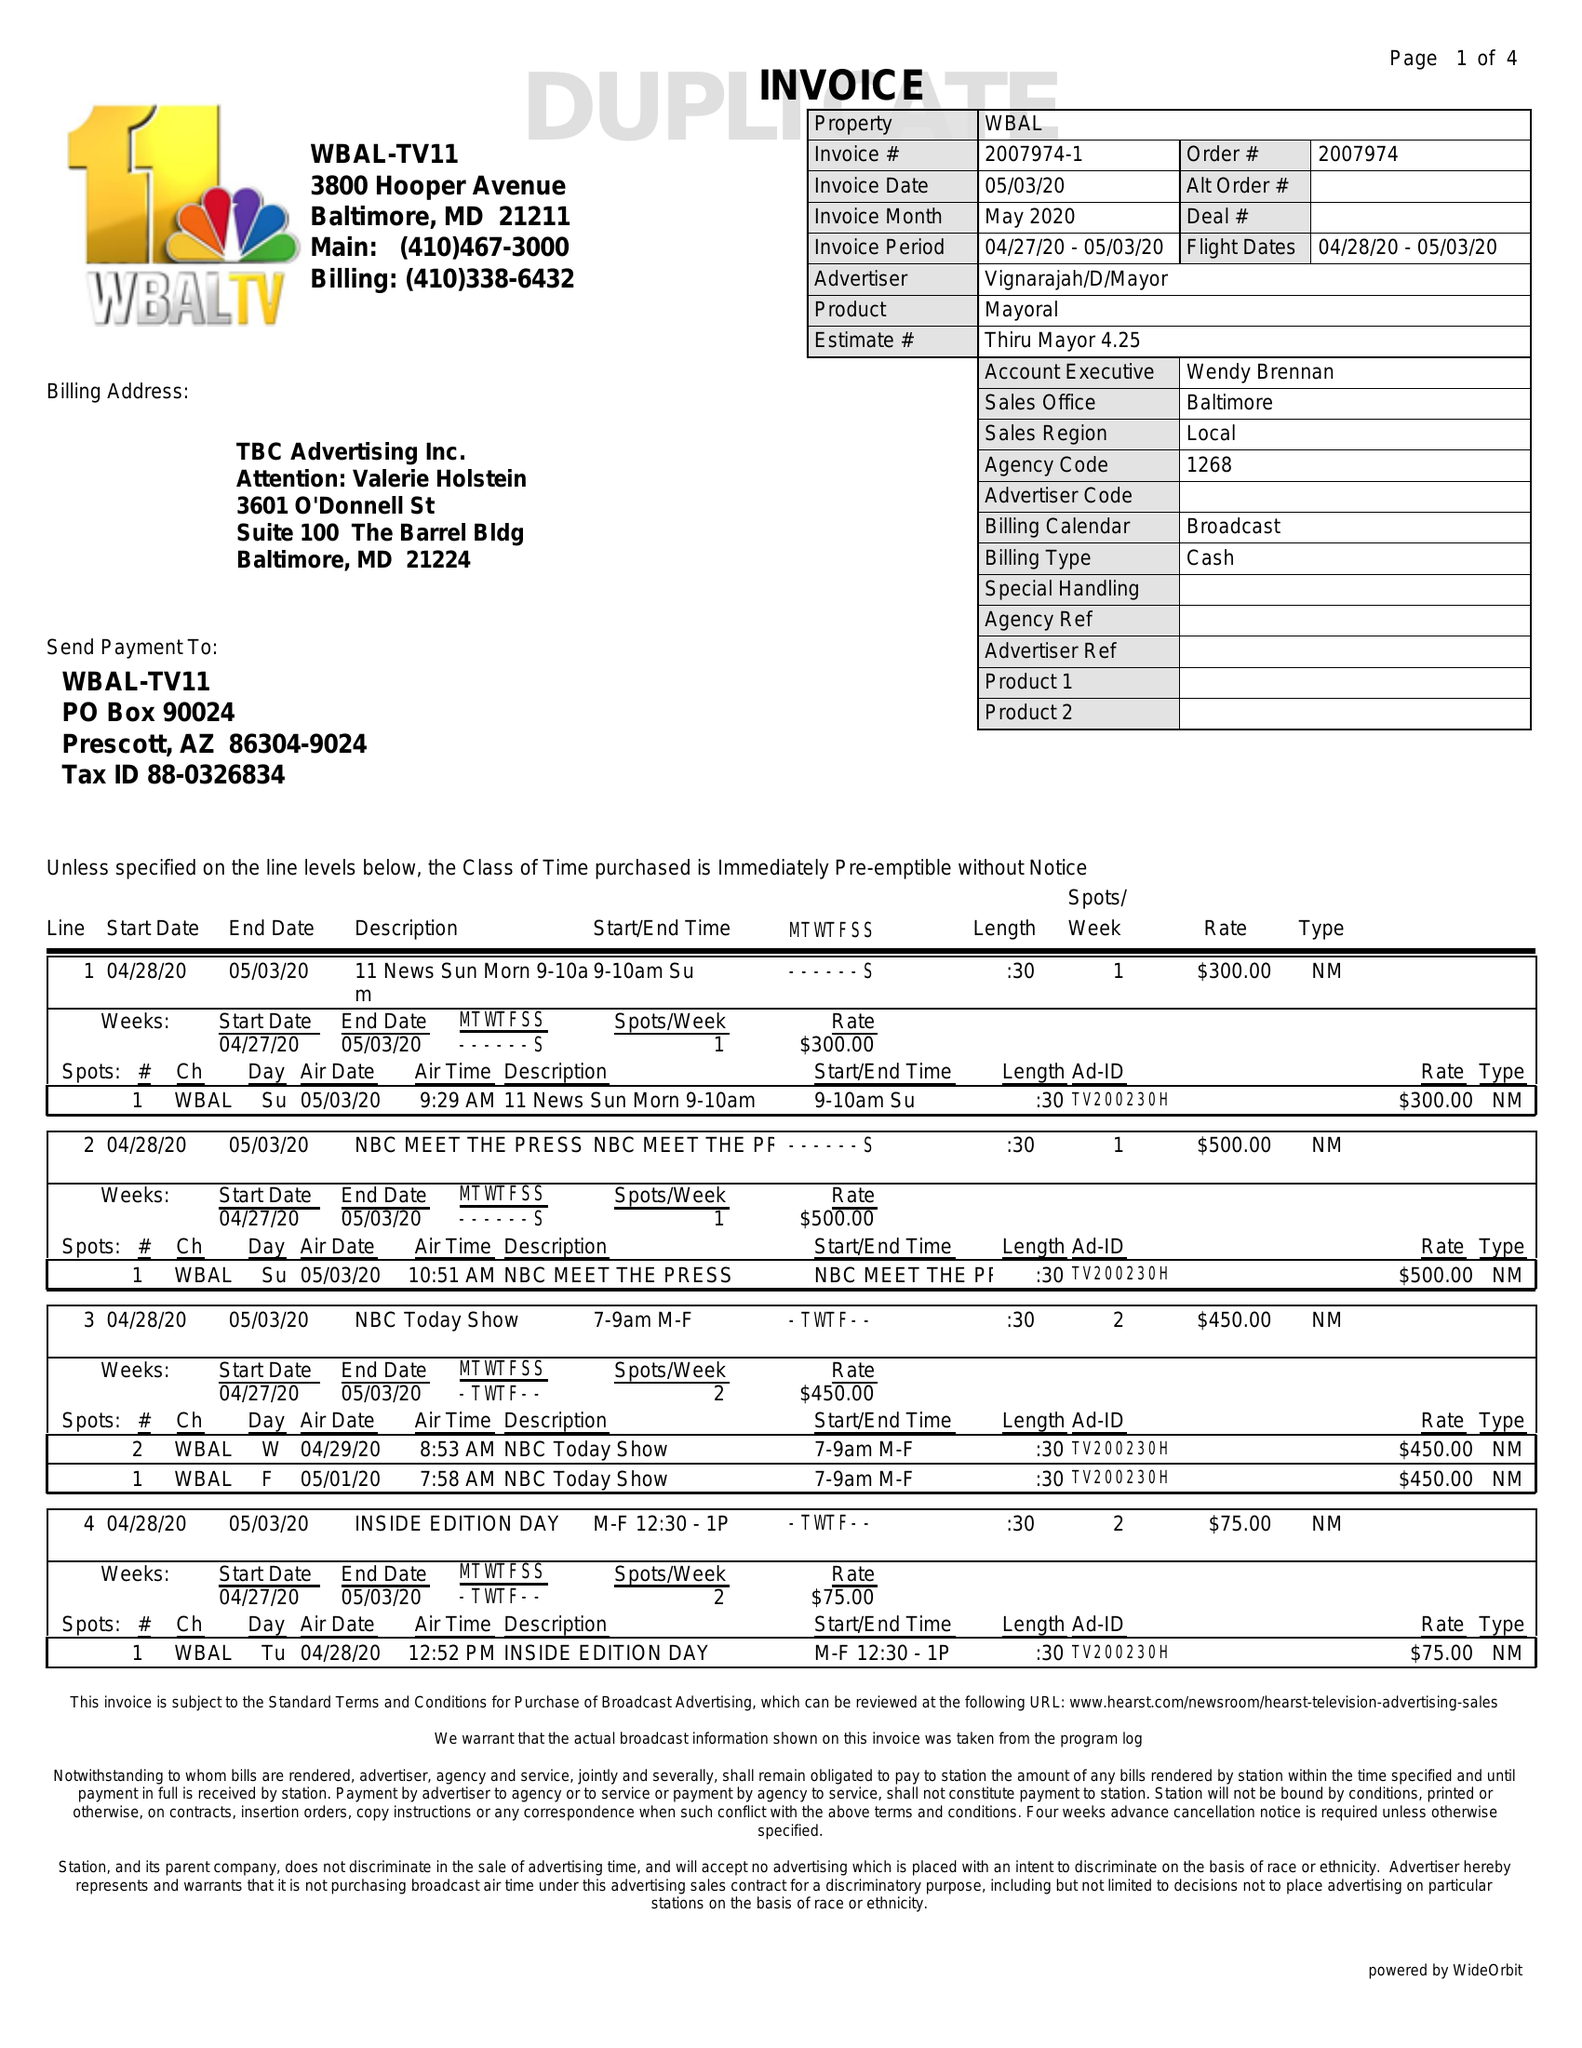What is the value for the gross_amount?
Answer the question using a single word or phrase. 9350.00 